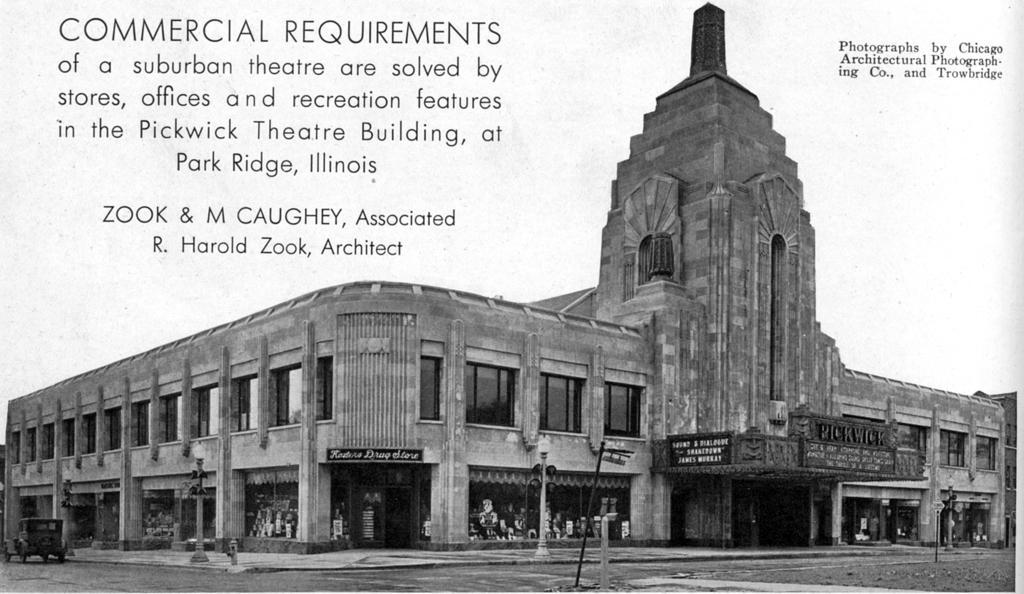Please provide a concise description of this image. In this picture we can see a vehicle on the road, here we can see electric poles with lights, flag, building and some objects, here we can see some text on it. 